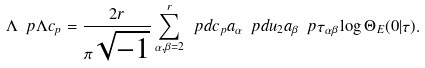<formula> <loc_0><loc_0><loc_500><loc_500>\Lambda \ p { \Lambda } c _ { p } = \frac { 2 r } { \pi \sqrt { - 1 } } \sum _ { \alpha , \beta = 2 } ^ { r } \ p d { c _ { p } } { a _ { \alpha } } \ p d { u _ { 2 } } { a _ { \beta } } \ p { \tau _ { \alpha \beta } } \log \Theta _ { E } ( 0 | \tau ) .</formula> 